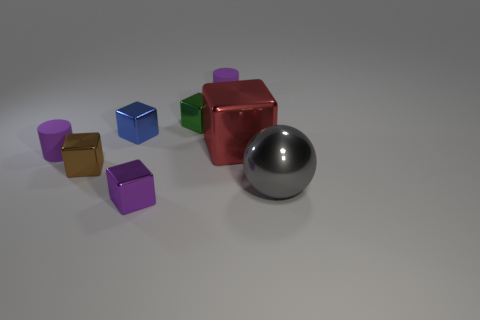Subtract all red cubes. How many cubes are left? 4 Subtract all big blocks. How many blocks are left? 4 Subtract all red blocks. Subtract all blue cylinders. How many blocks are left? 4 Add 1 metal objects. How many objects exist? 9 Subtract all cylinders. How many objects are left? 6 Add 3 small purple cubes. How many small purple cubes are left? 4 Add 4 gray metallic cylinders. How many gray metallic cylinders exist? 4 Subtract 0 brown cylinders. How many objects are left? 8 Subtract all metallic blocks. Subtract all big red cubes. How many objects are left? 2 